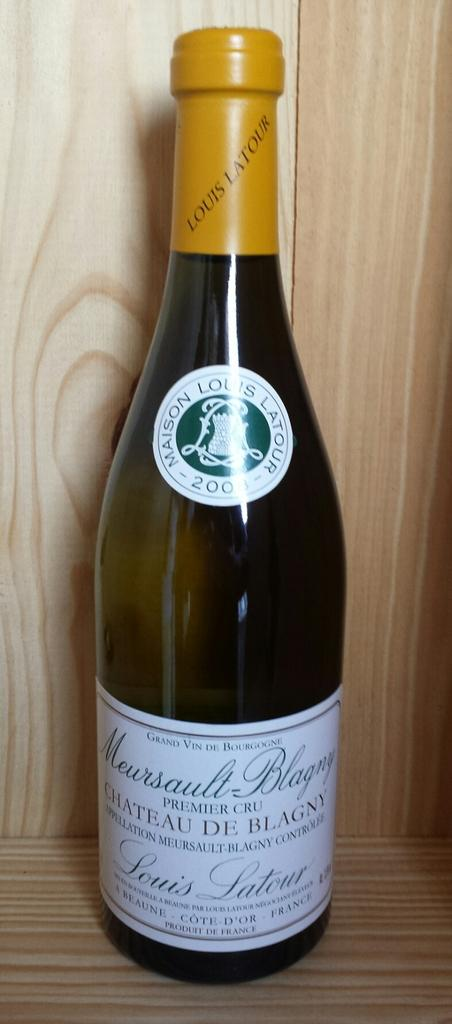<image>
Give a short and clear explanation of the subsequent image. A bottle of Maison Louis Latour branded wine in a wooden cabinet. 